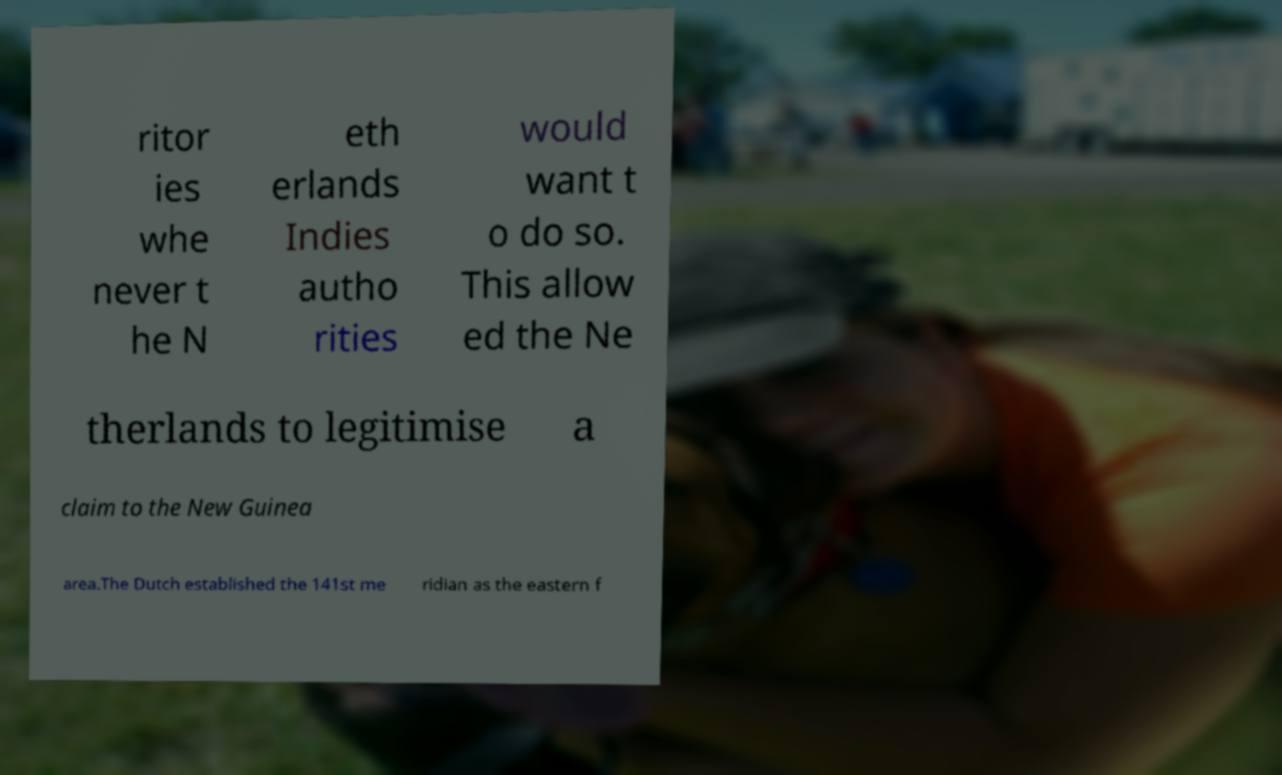Can you read and provide the text displayed in the image?This photo seems to have some interesting text. Can you extract and type it out for me? ritor ies whe never t he N eth erlands Indies autho rities would want t o do so. This allow ed the Ne therlands to legitimise a claim to the New Guinea area.The Dutch established the 141st me ridian as the eastern f 